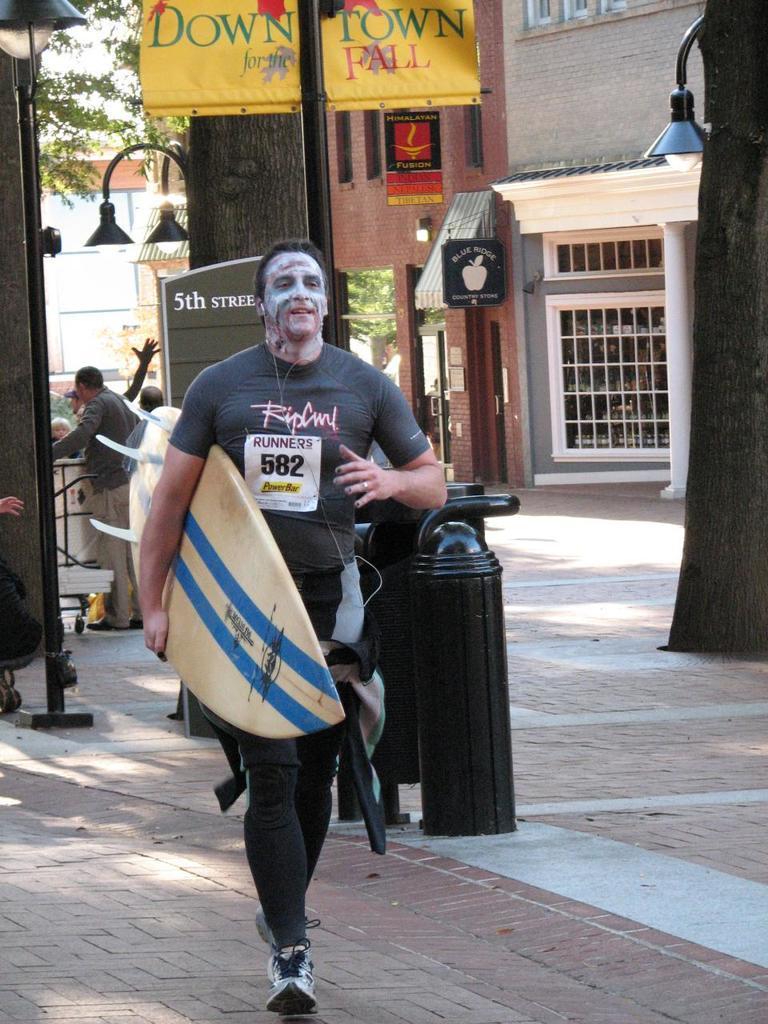Can you describe this image briefly? Here we can see a man walking with a surfboard in his hand and behind him we can see a building and at the left side we can see a couple of people standing 